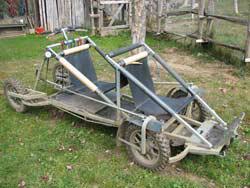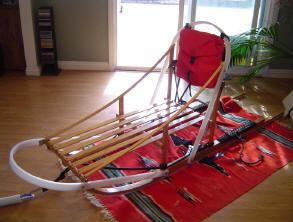The first image is the image on the left, the second image is the image on the right. Analyze the images presented: Is the assertion "The left image shows a dog in front of a riderless sled featuring red on it, and the right image shows a row of empty sleds." valid? Answer yes or no. No. The first image is the image on the left, the second image is the image on the right. Considering the images on both sides, is "In the image on the left there is one dog." valid? Answer yes or no. No. 